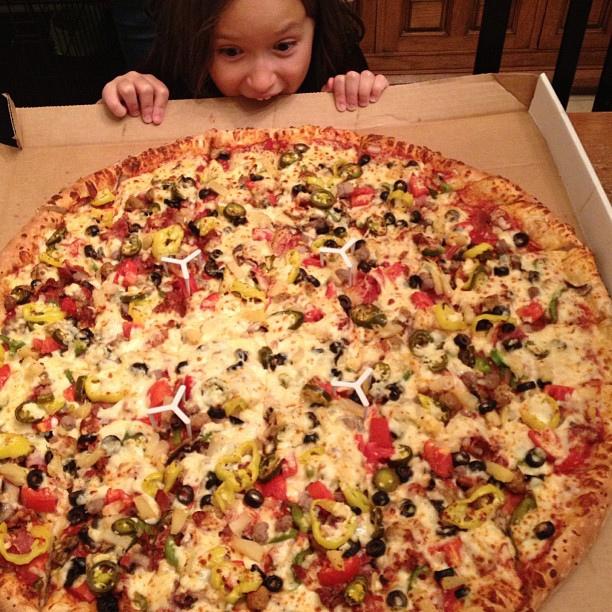Does the kid want to eat the pizza?
Quick response, please. Yes. Is this girl excited about eating cardboard?
Write a very short answer. No. What gender is the kid?
Give a very brief answer. Female. 